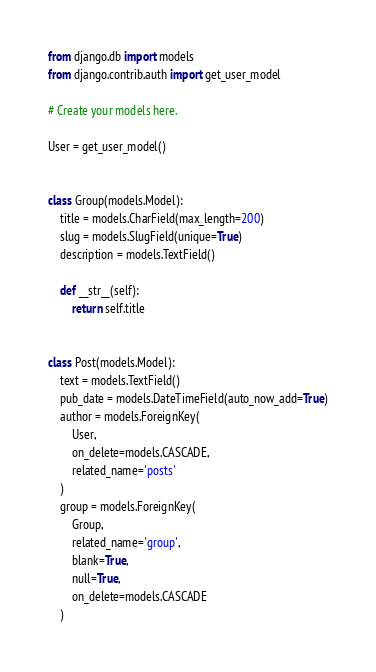Convert code to text. <code><loc_0><loc_0><loc_500><loc_500><_Python_>from django.db import models
from django.contrib.auth import get_user_model

# Create your models here.

User = get_user_model()


class Group(models.Model):
    title = models.CharField(max_length=200)
    slug = models.SlugField(unique=True)
    description = models.TextField()

    def __str__(self):
        return self.title


class Post(models.Model):
    text = models.TextField()
    pub_date = models.DateTimeField(auto_now_add=True)
    author = models.ForeignKey(
        User,
        on_delete=models.CASCADE,
        related_name='posts'
    )
    group = models.ForeignKey(
        Group,
        related_name='group',
        blank=True,
        null=True,
        on_delete=models.CASCADE
    )



</code> 